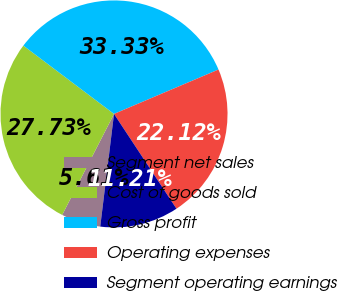<chart> <loc_0><loc_0><loc_500><loc_500><pie_chart><fcel>Segment net sales<fcel>Cost of goods sold<fcel>Gross profit<fcel>Operating expenses<fcel>Segment operating earnings<nl><fcel>5.61%<fcel>27.73%<fcel>33.33%<fcel>22.12%<fcel>11.21%<nl></chart> 